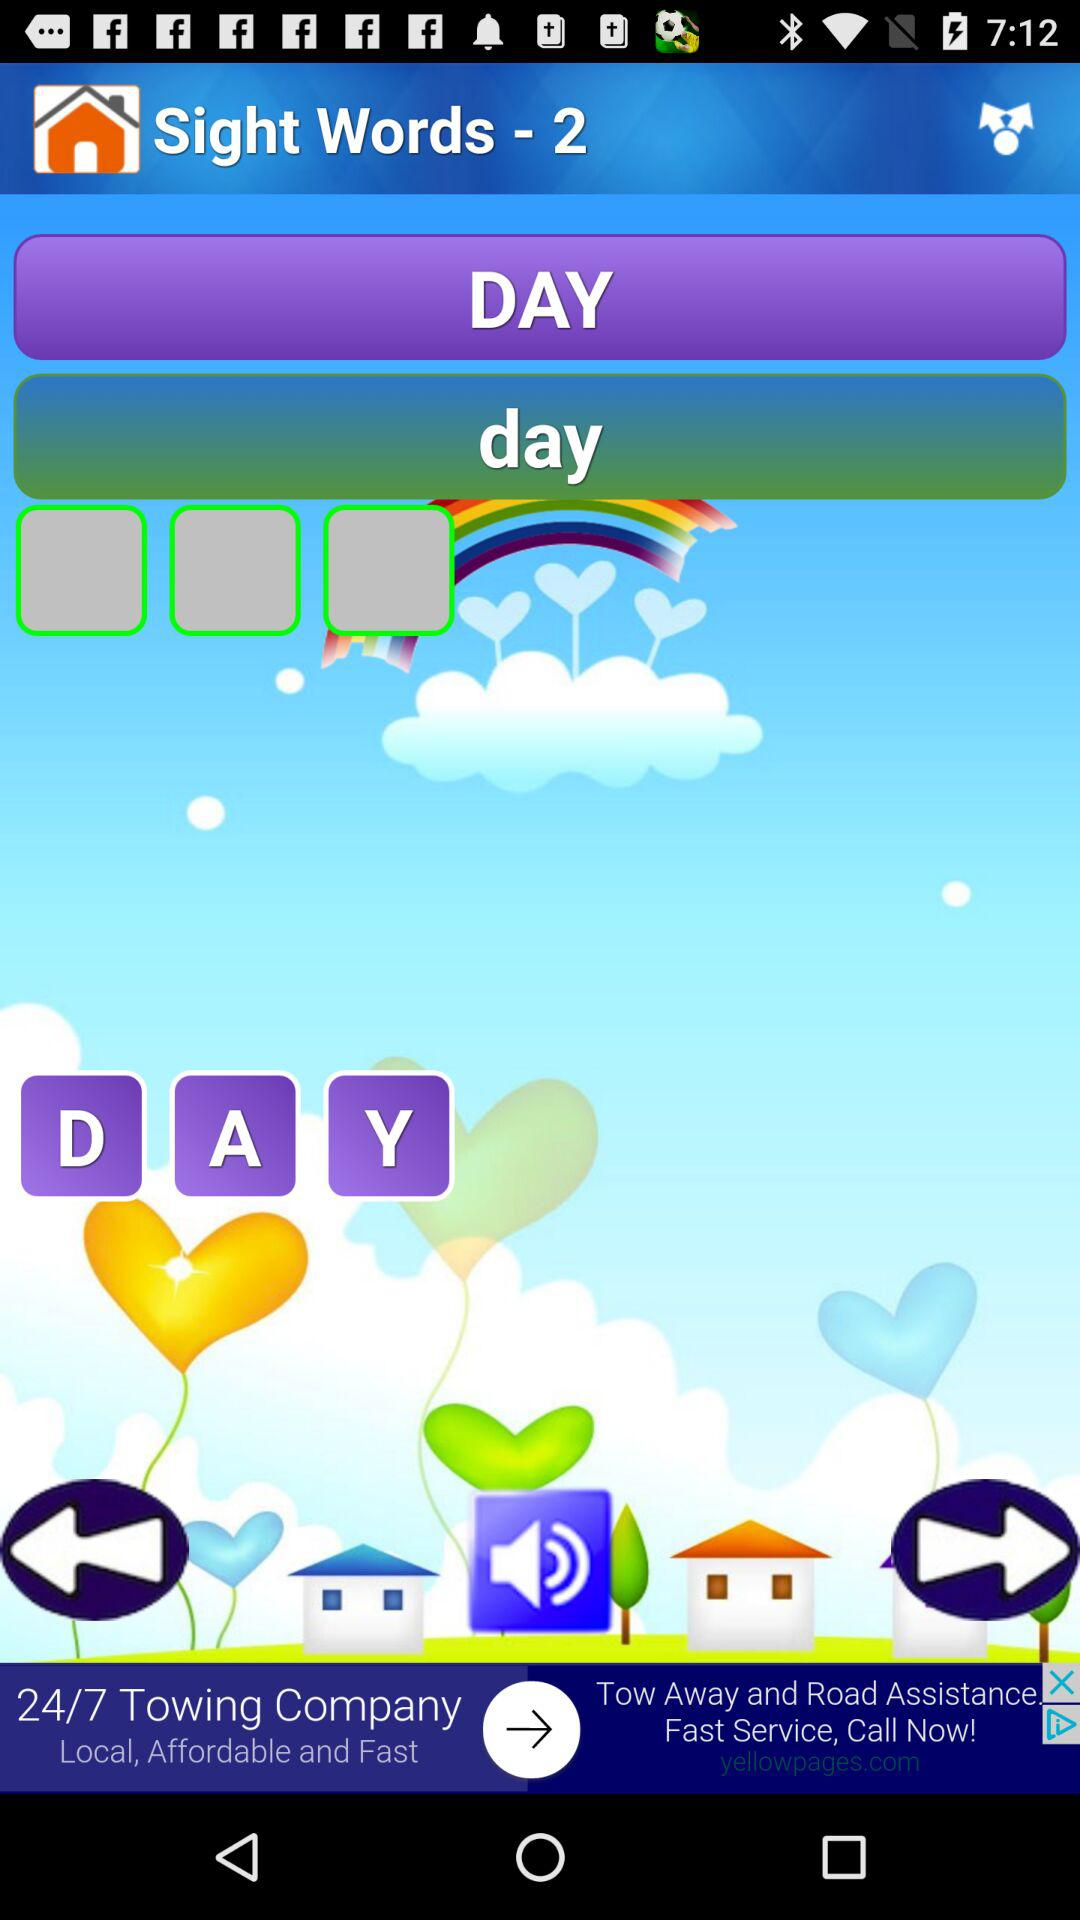How many input boxes are there?
Answer the question using a single word or phrase. 3 